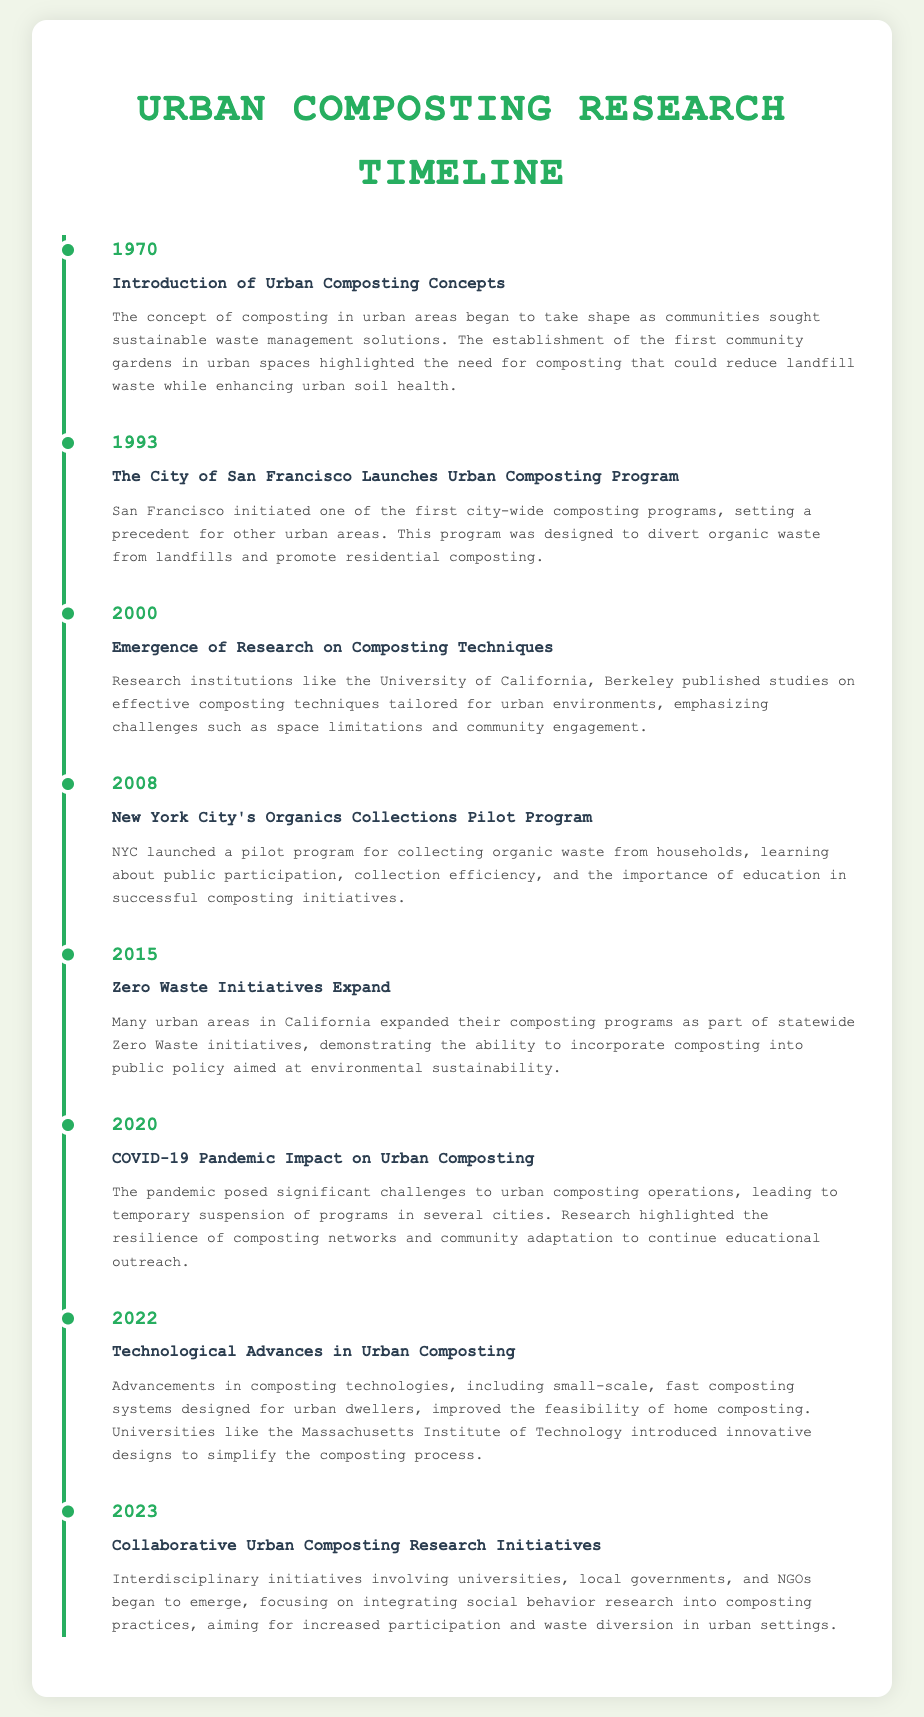what year was the concept of urban composting introduced? The document states that the concept of composting in urban areas began to take shape in 1970.
Answer: 1970 which city launched an urban composting program in 1993? According to the timeline, San Francisco initiated one of the first city-wide composting programs in 1993.
Answer: San Francisco what significant event impacted urban composting in 2020? The document mentions that the COVID-19 pandemic posed significant challenges to urban composting operations in 2020.
Answer: COVID-19 pandemic which initiative in 2015 expanded composting programs in California? The timeline indicates that Zero Waste initiatives expanded composting programs in California in 2015.
Answer: Zero Waste initiatives what new technologies emerged for urban composting in 2022? The document discusses advancements in composting technologies, including small-scale, fast composting systems designed for urban dwellers in 2022.
Answer: Technological Advances what was the focus of research initiatives in 2023? The timeline highlights that interdisciplinary initiatives in 2023 focused on integrating social behavior research into composting practices.
Answer: Collaborative Urban Composting Research Initiatives how far apart are the milestones in the timeline? The years mentioned in the timeline range from 1970 to 2023, roughly spanning 53 years.
Answer: 53 years what was a major challenge identified in 2008 regarding composting programs? The document mentions that the 2008 pilot program in New York City learned about the importance of education in successful composting initiatives.
Answer: Education necessity what type of document is this timeline categorized under? The content primarily focuses on historical developments and achievements in urban composting practices.
Answer: Research timeline 